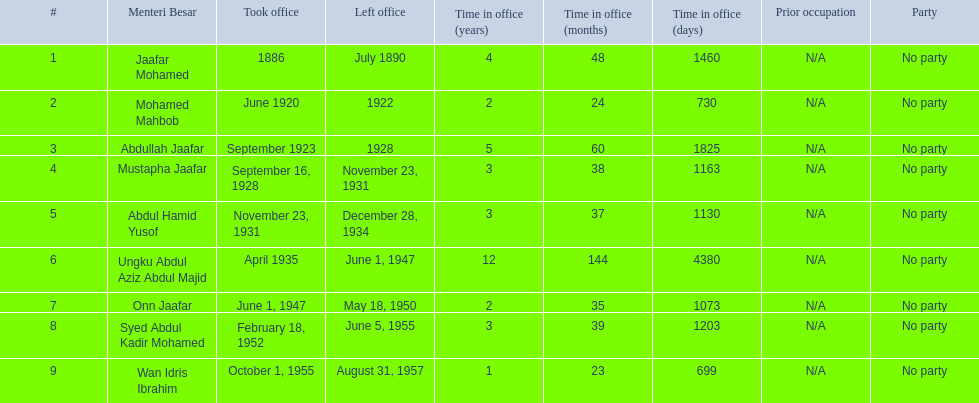What are all the people that were menteri besar of johor? Jaafar Mohamed, Mohamed Mahbob, Abdullah Jaafar, Mustapha Jaafar, Abdul Hamid Yusof, Ungku Abdul Aziz Abdul Majid, Onn Jaafar, Syed Abdul Kadir Mohamed, Wan Idris Ibrahim. Who ruled the longest? Ungku Abdul Aziz Abdul Majid. 